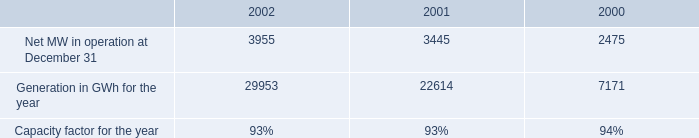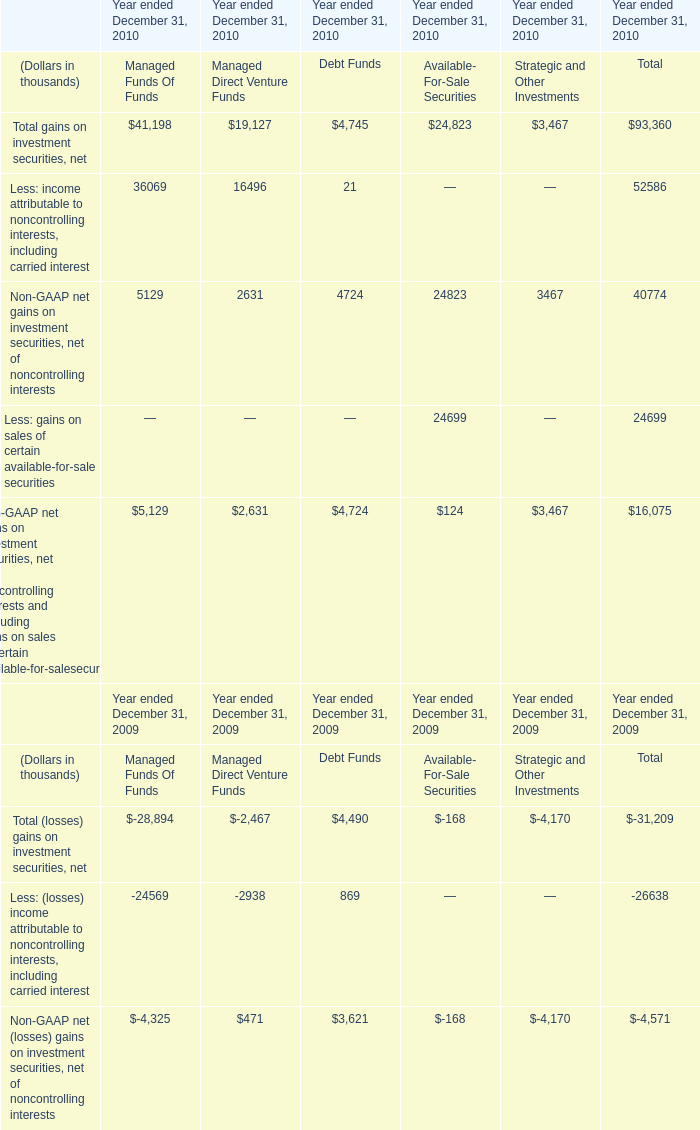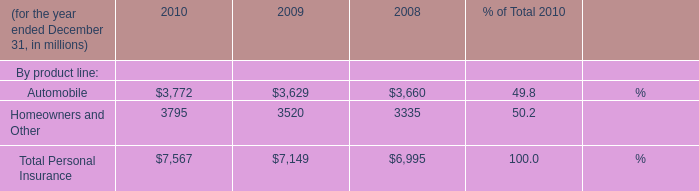what is the percent change in earnings for non-utility nuclear from 2001 to 2002? 
Computations: ((201 - 128) / 128)
Answer: 0.57031. 